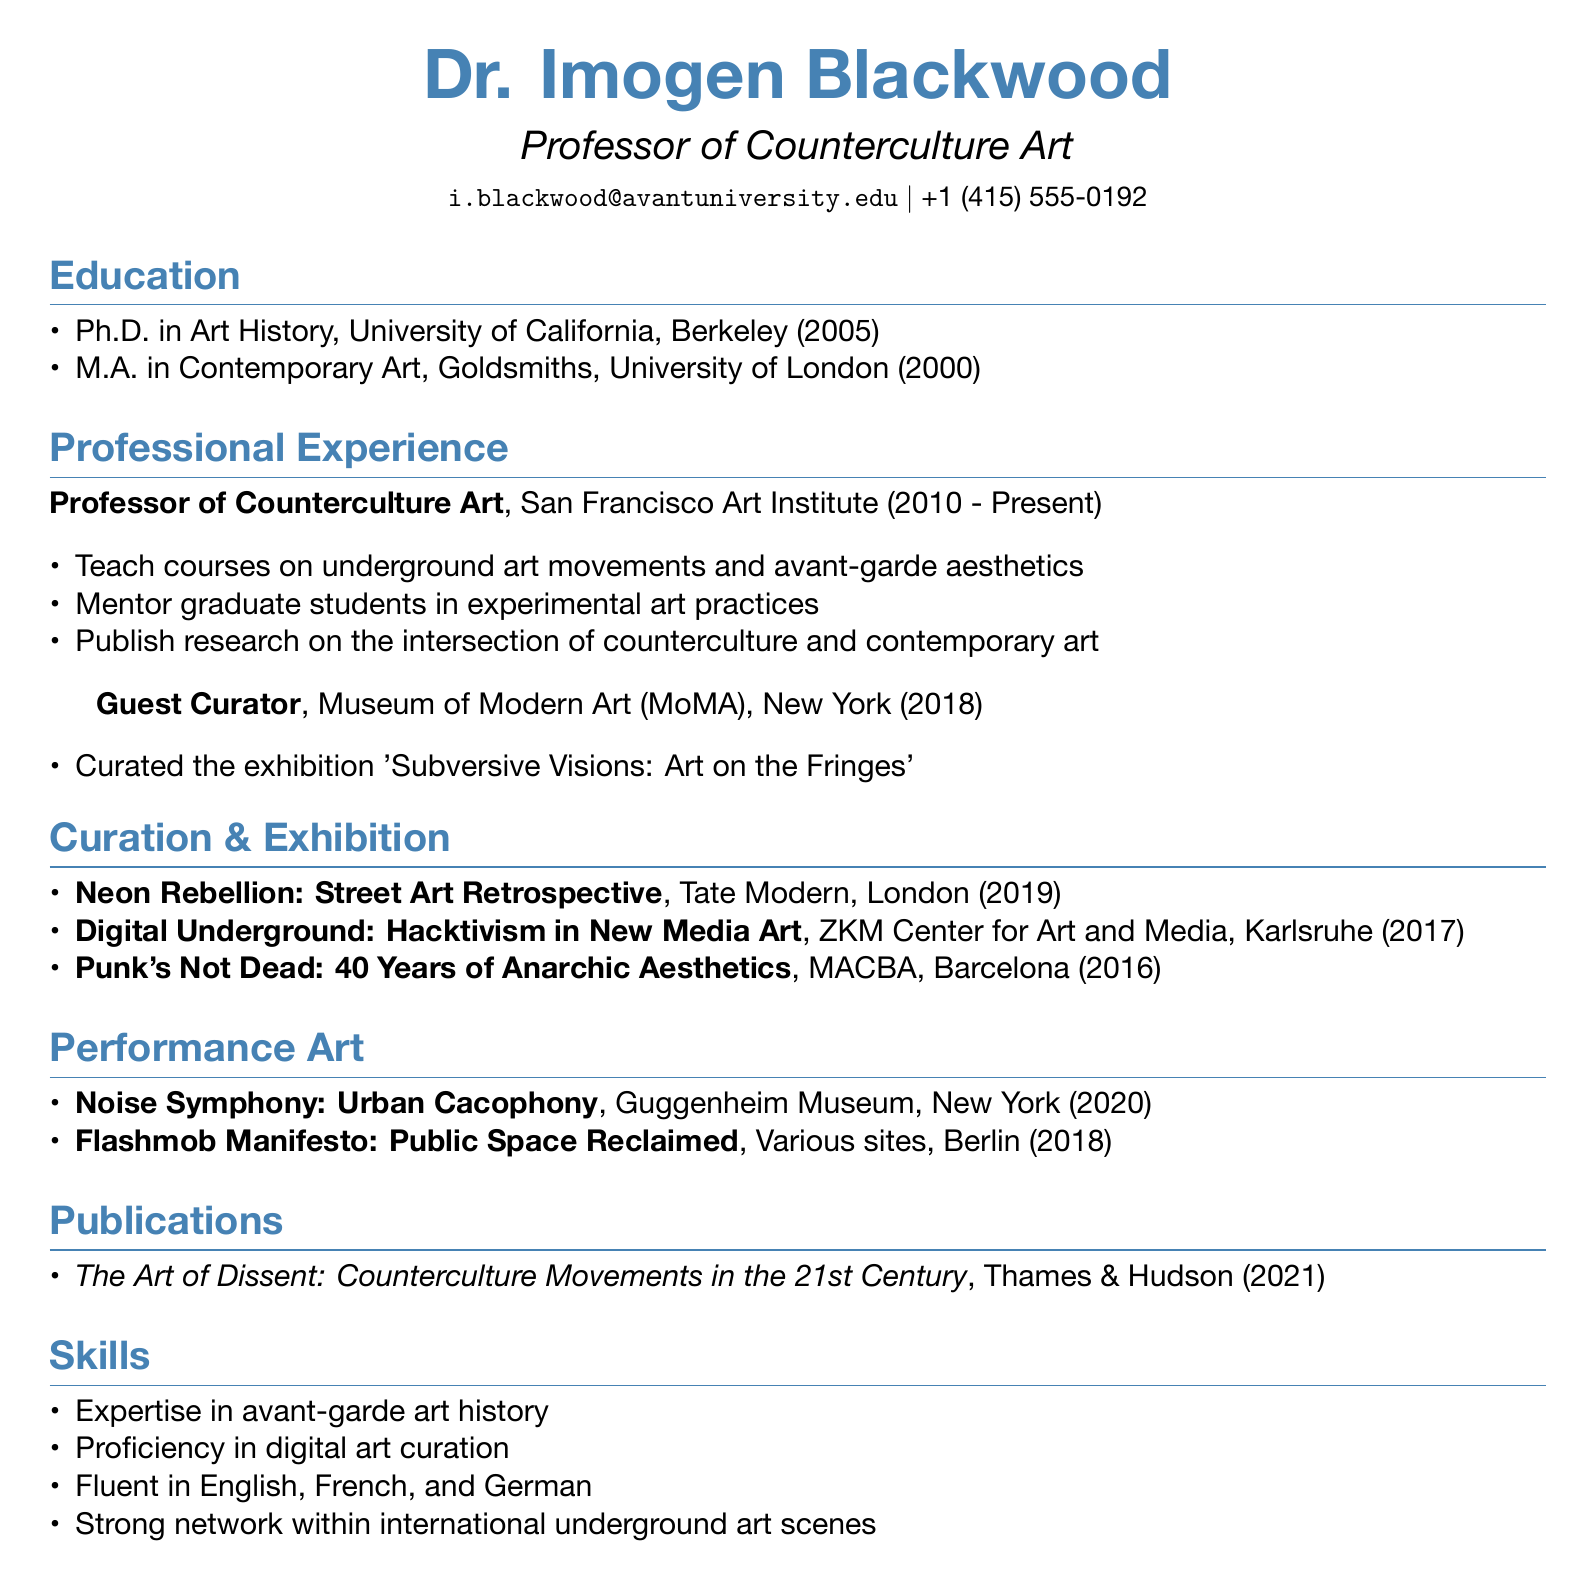What is Dr. Imogen Blackwood's title? Dr. Imogen Blackwood is identified as a Professor of Counterculture Art in the document.
Answer: Professor of Counterculture Art Which institution did Dr. Blackwood receive her Ph.D. from? The document states that Dr. Blackwood earned her Ph.D. from the University of California, Berkeley.
Answer: University of California, Berkeley In which year did Dr. Blackwood curate the exhibition "Subversive Visions: Art on the Fringes"? The document mentions that the exhibition was curated in the year 2018.
Answer: 2018 What is one skill that Dr. Blackwood has? The document lists several skills, including expertise in avant-garde art history.
Answer: Expertise in avant-garde art history How many years has Dr. Blackwood been a professor at the San Francisco Art Institute? The document indicates that Dr. Blackwood has been a professor from 2010 to the present, suggesting she has been in that role for approximately 13 years.
Answer: 13 years What is the title of Dr. Blackwood's publication released in 2021? The document provides the title of the publication as "The Art of Dissent: Counterculture Movements in the 21st Century."
Answer: The Art of Dissent: Counterculture Movements in the 21st Century Name a venue where Dr. Blackwood's performance "Noise Symphony: Urban Cacophony" took place. The document specifies that the performance took place at the Guggenheim Museum in New York.
Answer: Guggenheim Museum, New York What type of exhibitions has Dr. Blackwood curated? The document outlines that Dr. Blackwood has curated exhibitions focused on underground art and avant-garde themes.
Answer: Underground art and avant-garde themes 